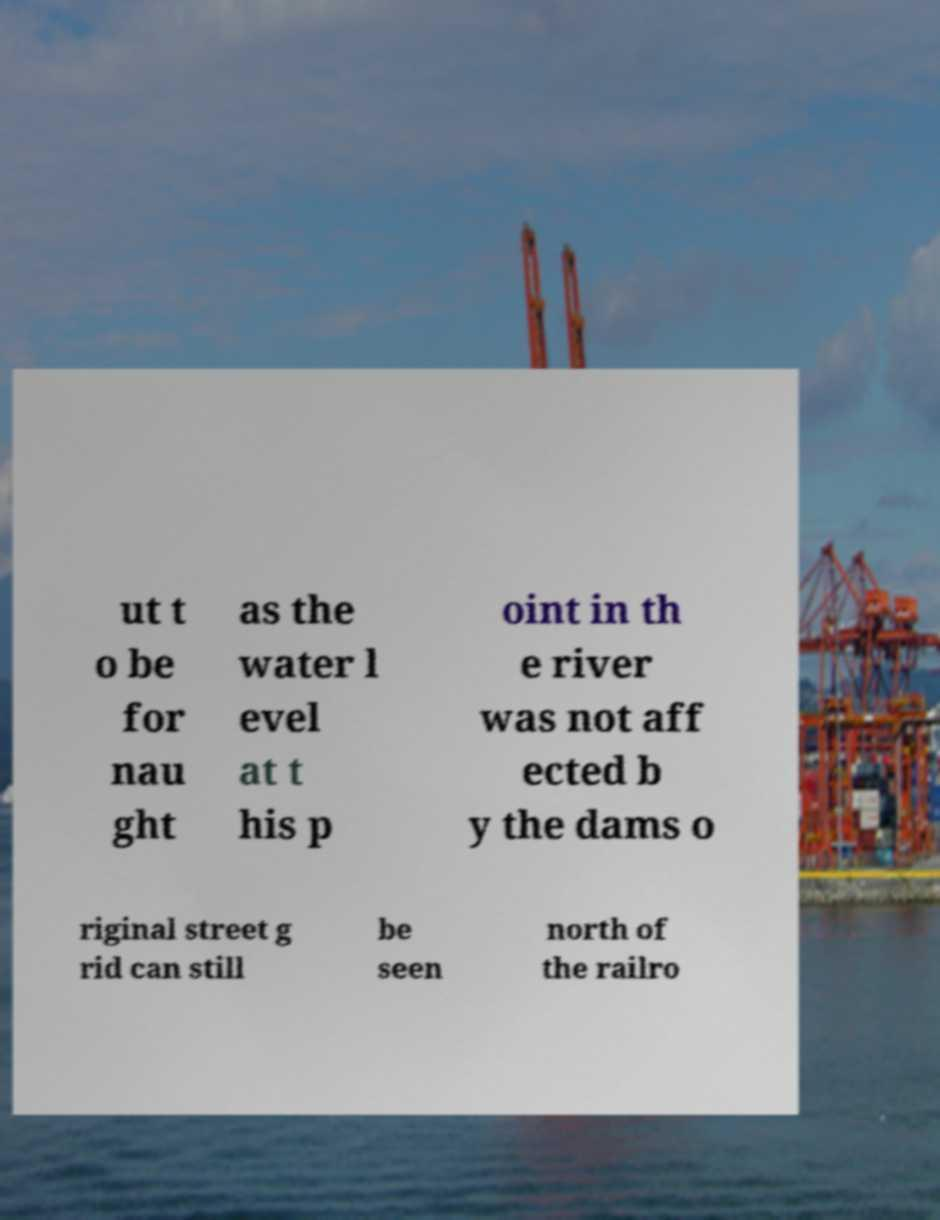There's text embedded in this image that I need extracted. Can you transcribe it verbatim? ut t o be for nau ght as the water l evel at t his p oint in th e river was not aff ected b y the dams o riginal street g rid can still be seen north of the railro 